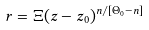Convert formula to latex. <formula><loc_0><loc_0><loc_500><loc_500>r = \Xi ( z - z _ { 0 } ) ^ { n / [ \Theta _ { 0 } - n ] }</formula> 